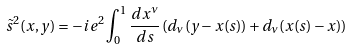Convert formula to latex. <formula><loc_0><loc_0><loc_500><loc_500>\tilde { s } ^ { 2 } ( x , y ) = - i e ^ { 2 } \int _ { 0 } ^ { 1 } \frac { d x ^ { \nu } } { d s } \, ( d _ { \nu } ( y - x ( s ) ) + d _ { \nu } ( x ( s ) - x ) )</formula> 